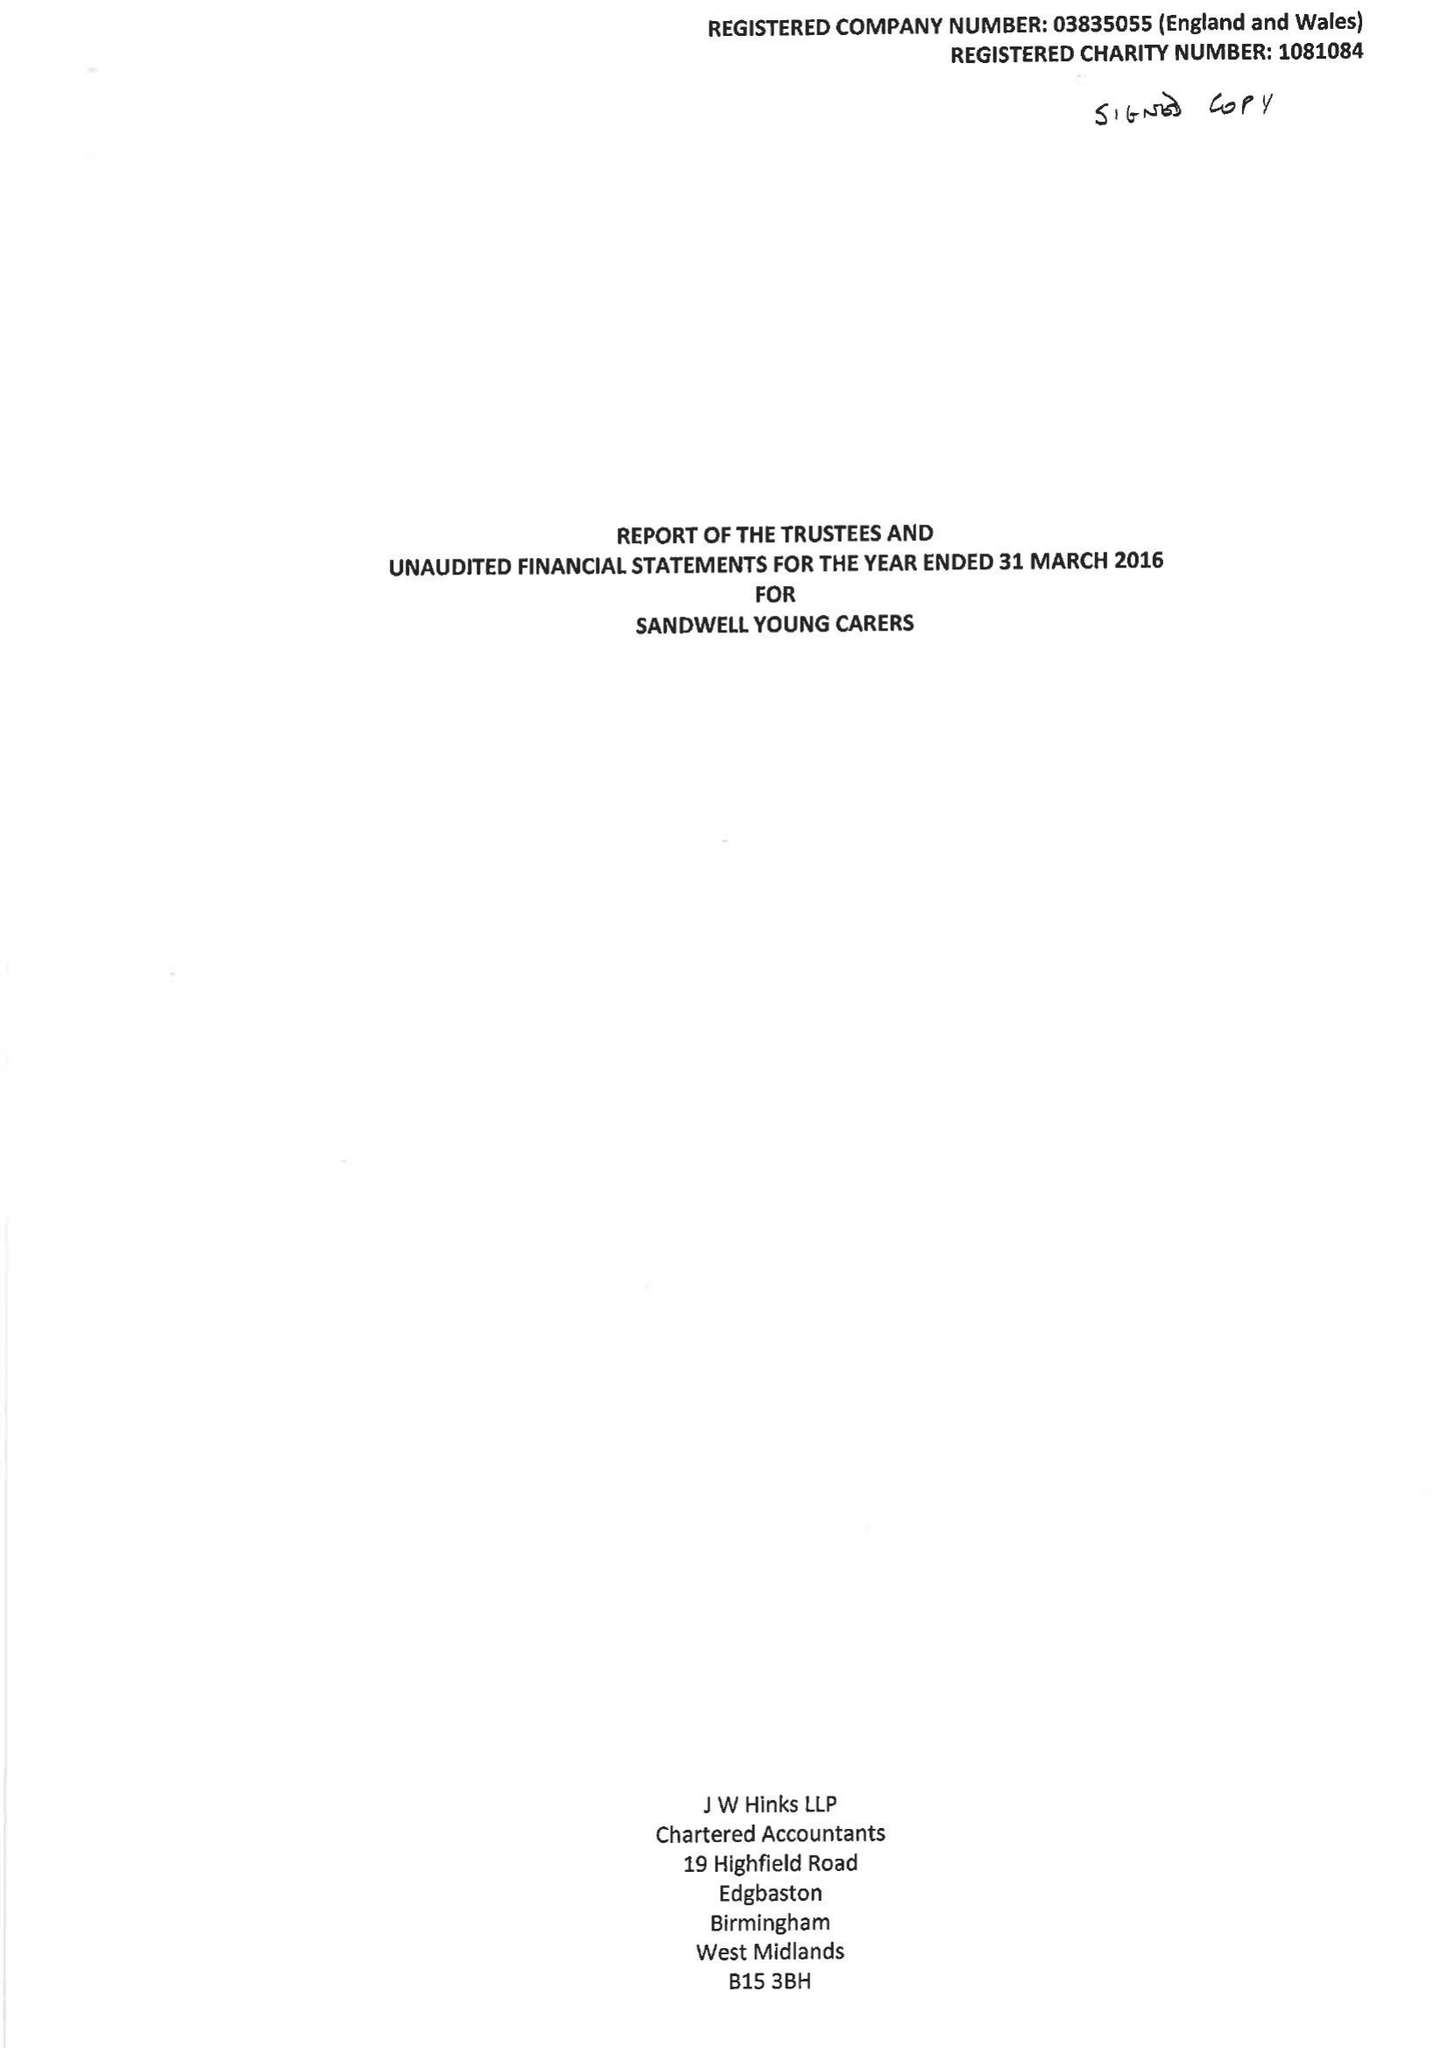What is the value for the charity_name?
Answer the question using a single word or phrase. Sandwell Young Carers 